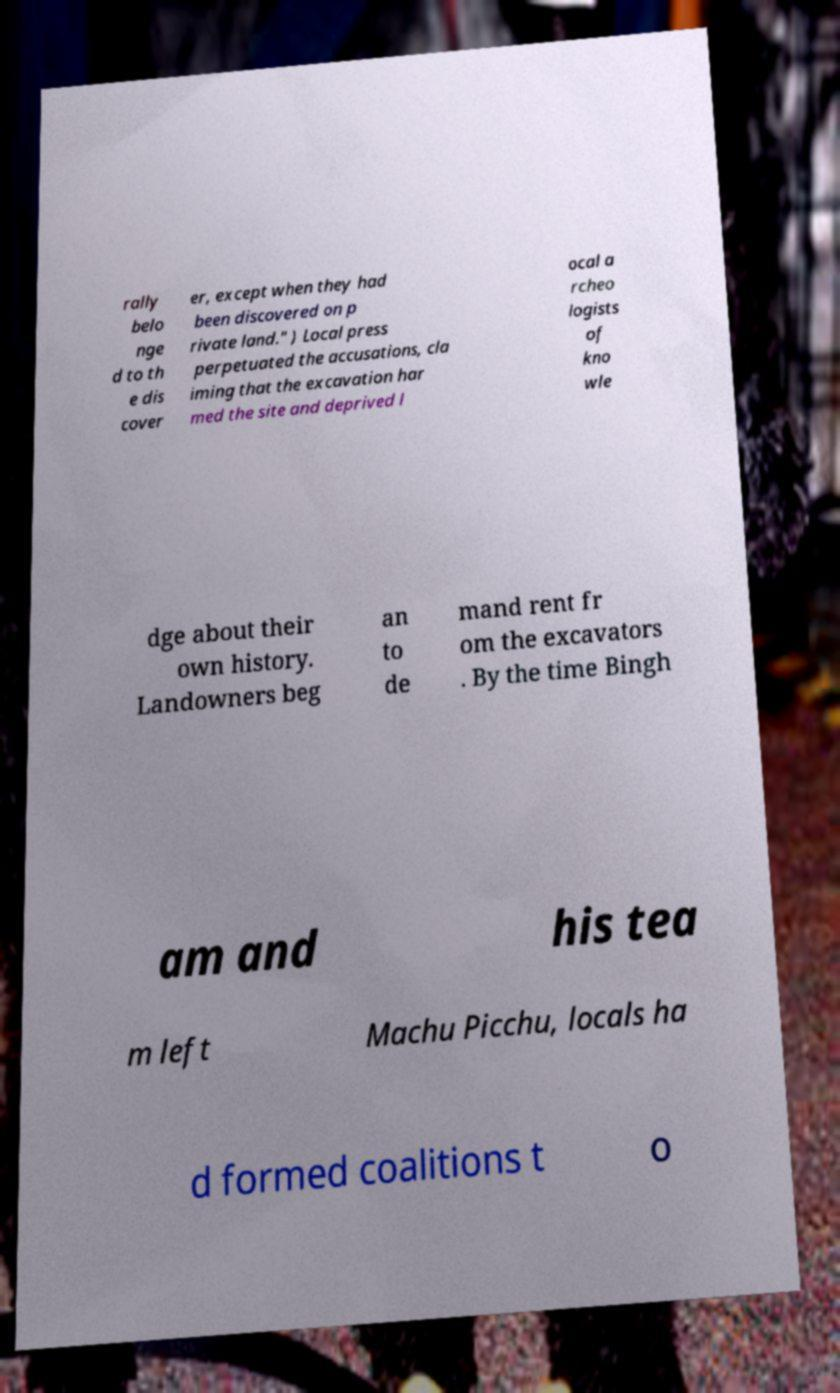There's text embedded in this image that I need extracted. Can you transcribe it verbatim? rally belo nge d to th e dis cover er, except when they had been discovered on p rivate land." ) Local press perpetuated the accusations, cla iming that the excavation har med the site and deprived l ocal a rcheo logists of kno wle dge about their own history. Landowners beg an to de mand rent fr om the excavators . By the time Bingh am and his tea m left Machu Picchu, locals ha d formed coalitions t o 